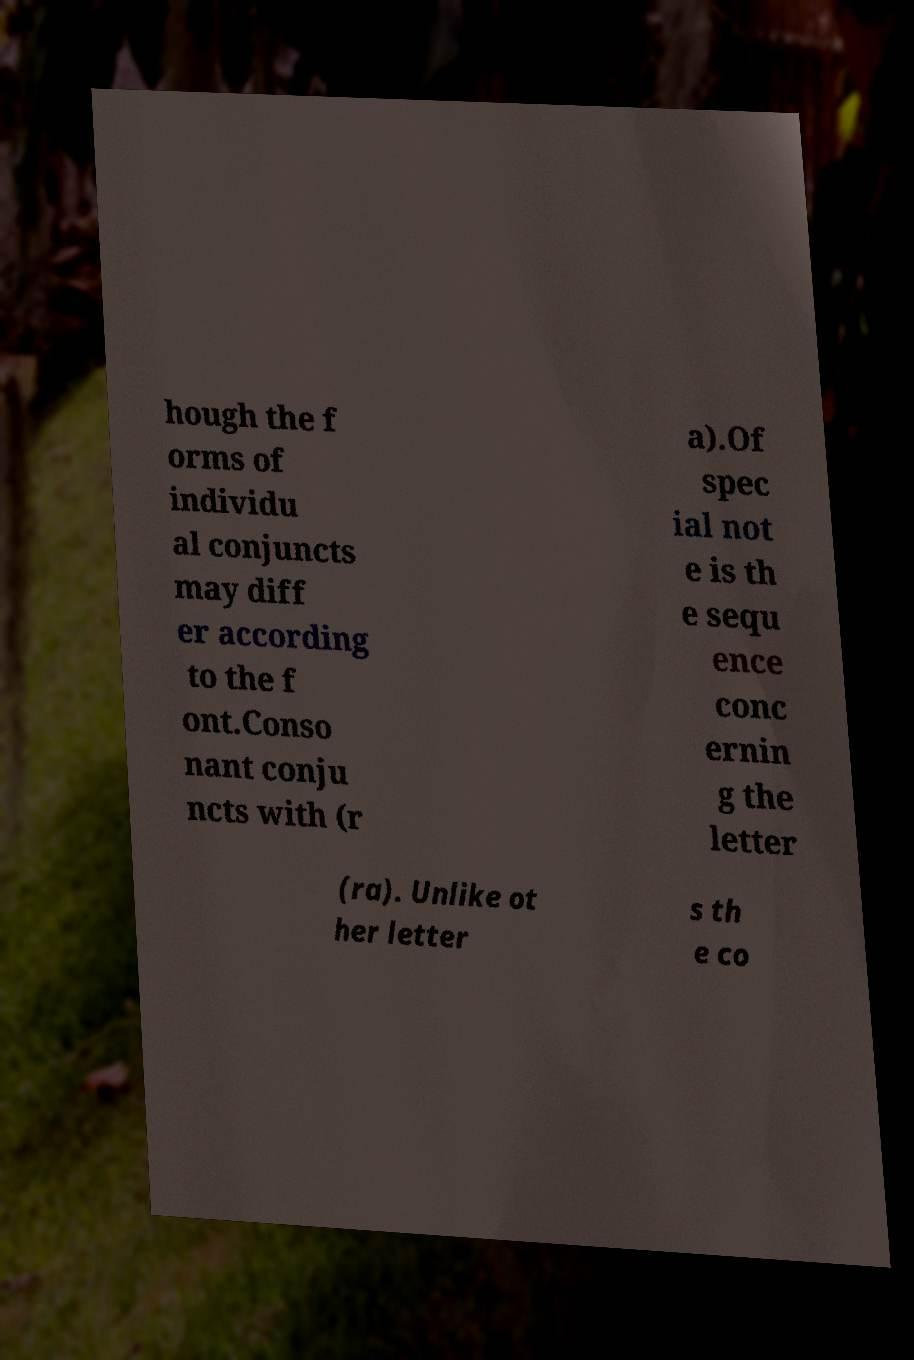Could you extract and type out the text from this image? hough the f orms of individu al conjuncts may diff er according to the f ont.Conso nant conju ncts with (r a).Of spec ial not e is th e sequ ence conc ernin g the letter (ra). Unlike ot her letter s th e co 